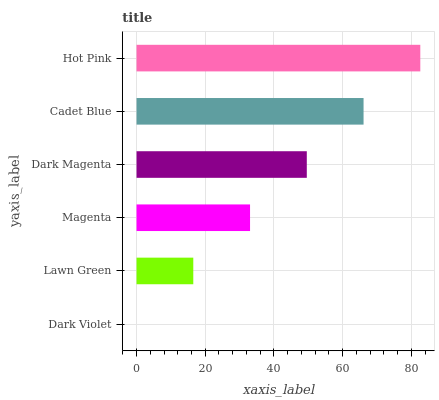Is Dark Violet the minimum?
Answer yes or no. Yes. Is Hot Pink the maximum?
Answer yes or no. Yes. Is Lawn Green the minimum?
Answer yes or no. No. Is Lawn Green the maximum?
Answer yes or no. No. Is Lawn Green greater than Dark Violet?
Answer yes or no. Yes. Is Dark Violet less than Lawn Green?
Answer yes or no. Yes. Is Dark Violet greater than Lawn Green?
Answer yes or no. No. Is Lawn Green less than Dark Violet?
Answer yes or no. No. Is Dark Magenta the high median?
Answer yes or no. Yes. Is Magenta the low median?
Answer yes or no. Yes. Is Magenta the high median?
Answer yes or no. No. Is Lawn Green the low median?
Answer yes or no. No. 